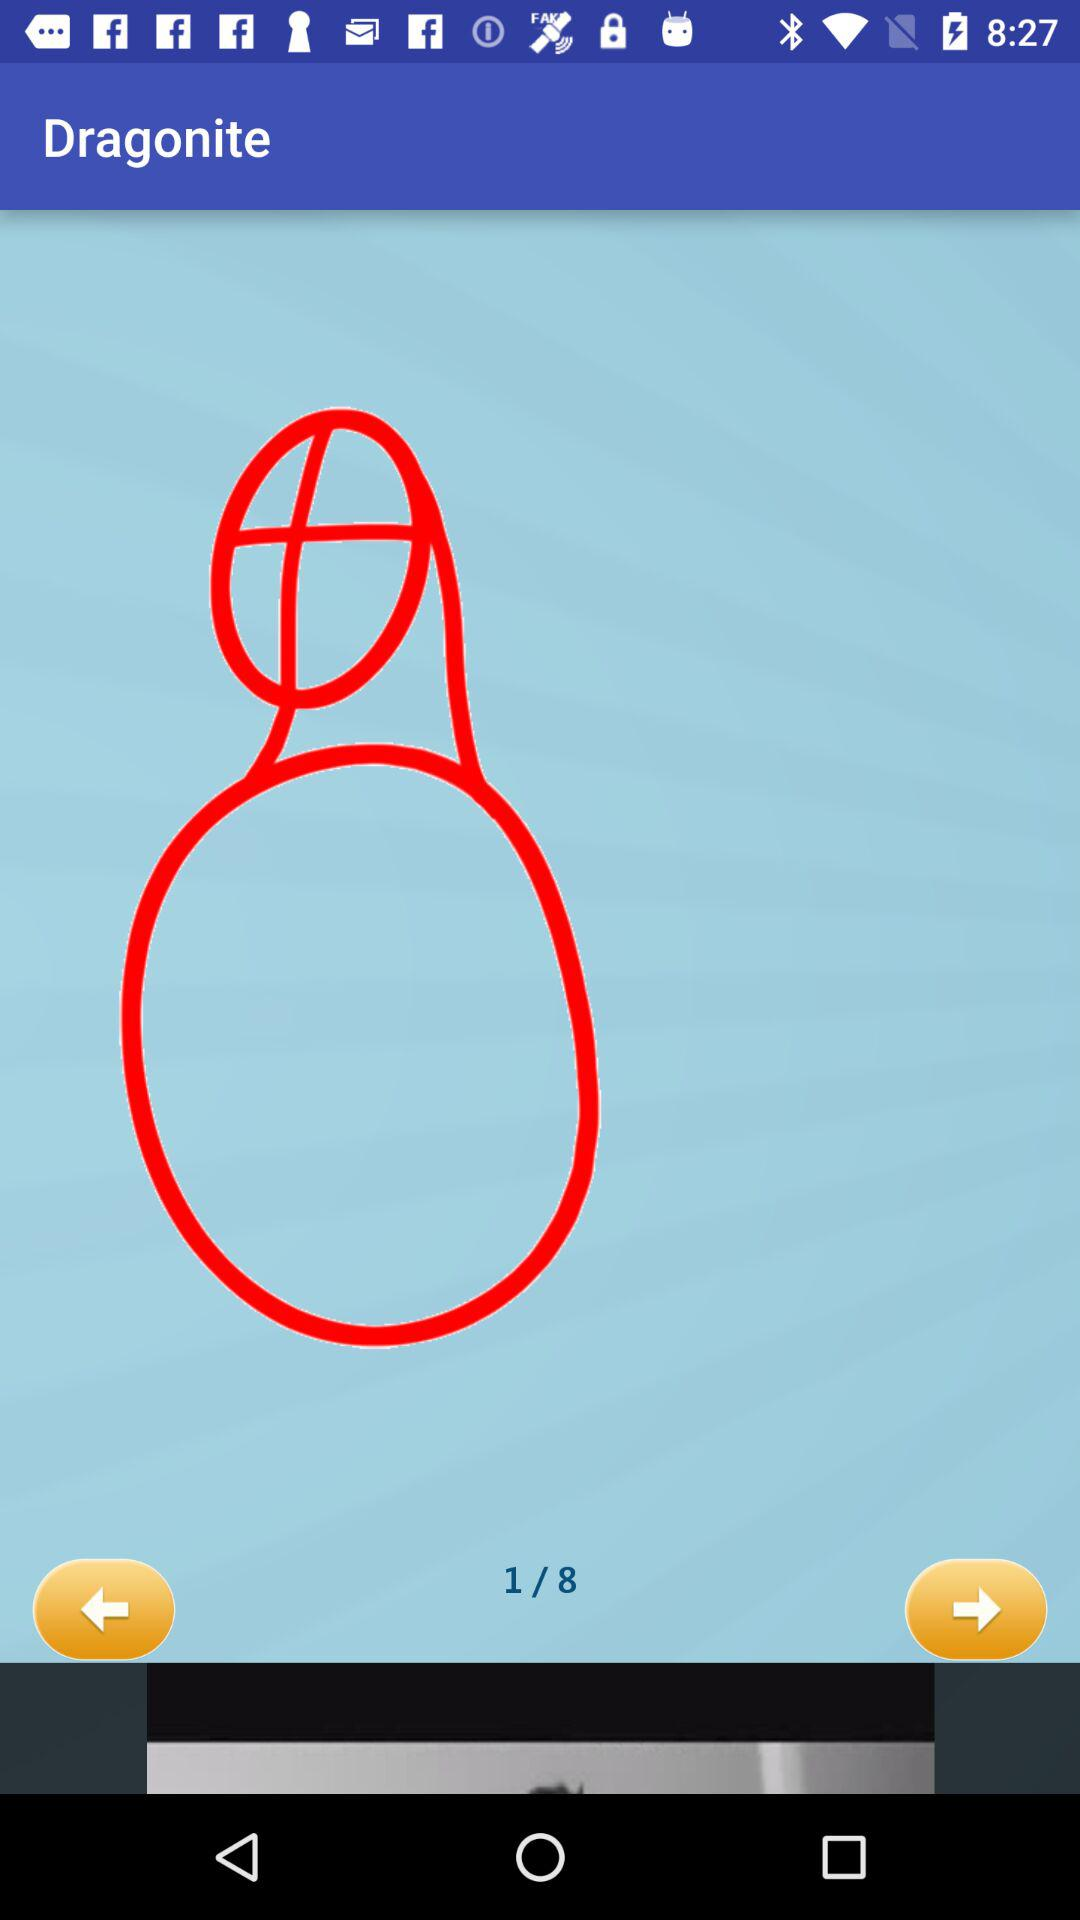How many images in total are there? There are 8 images. 